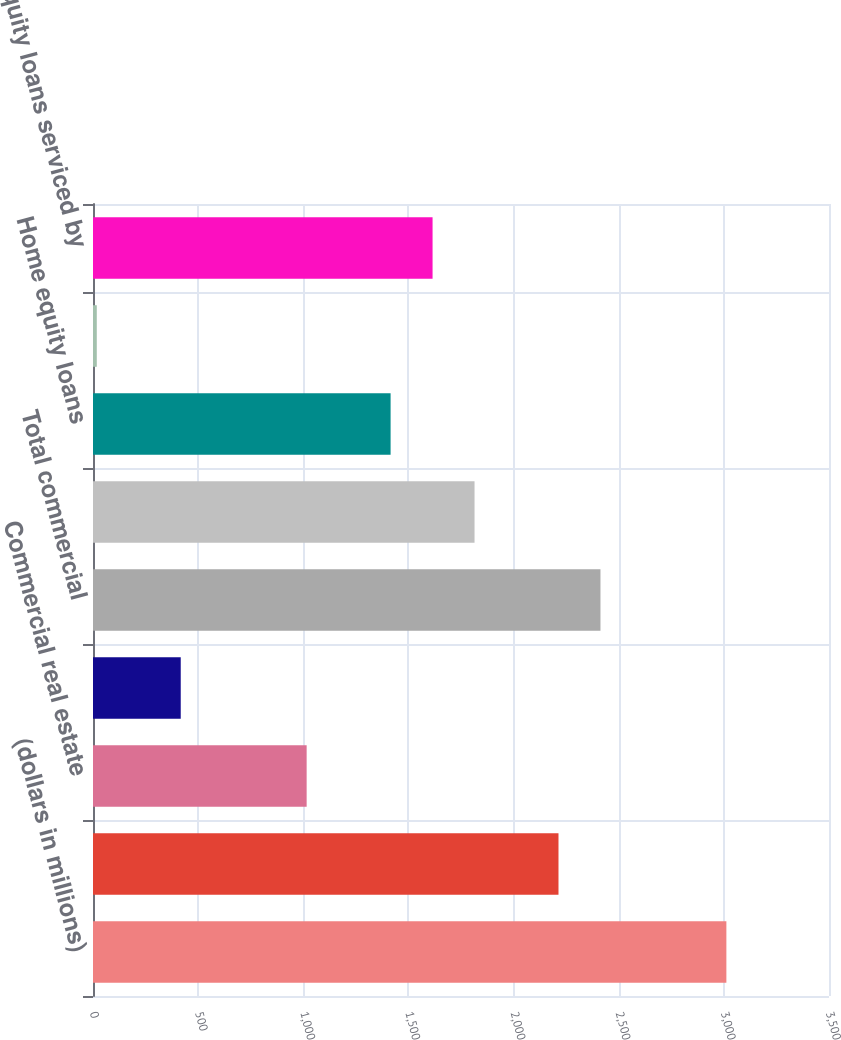Convert chart. <chart><loc_0><loc_0><loc_500><loc_500><bar_chart><fcel>(dollars in millions)<fcel>Commercial<fcel>Commercial real estate<fcel>Leases<fcel>Total commercial<fcel>Residential mortgages<fcel>Home equity loans<fcel>Home equity lines of credit<fcel>Home equity loans serviced by<nl><fcel>3012<fcel>2213.6<fcel>1016<fcel>417.2<fcel>2413.2<fcel>1814.4<fcel>1415.2<fcel>18<fcel>1614.8<nl></chart> 